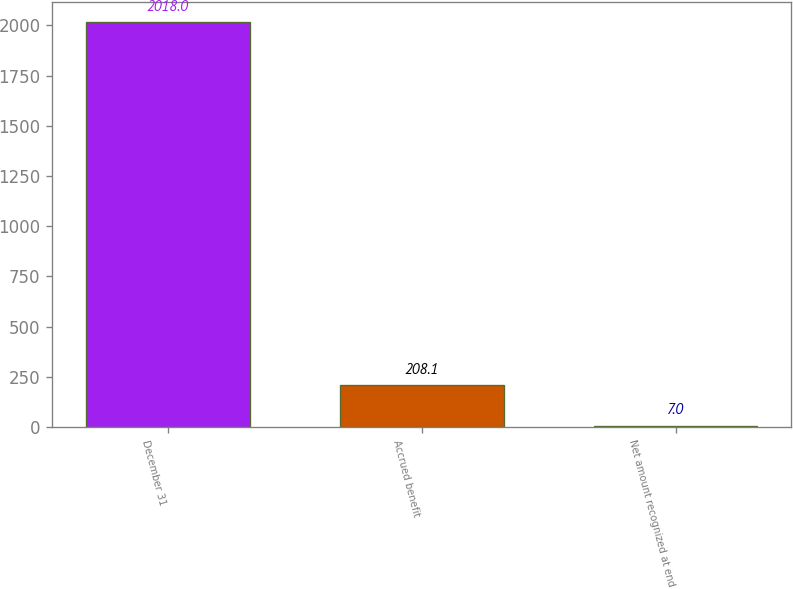Convert chart to OTSL. <chart><loc_0><loc_0><loc_500><loc_500><bar_chart><fcel>December 31<fcel>Accrued benefit<fcel>Net amount recognized at end<nl><fcel>2018<fcel>208.1<fcel>7<nl></chart> 